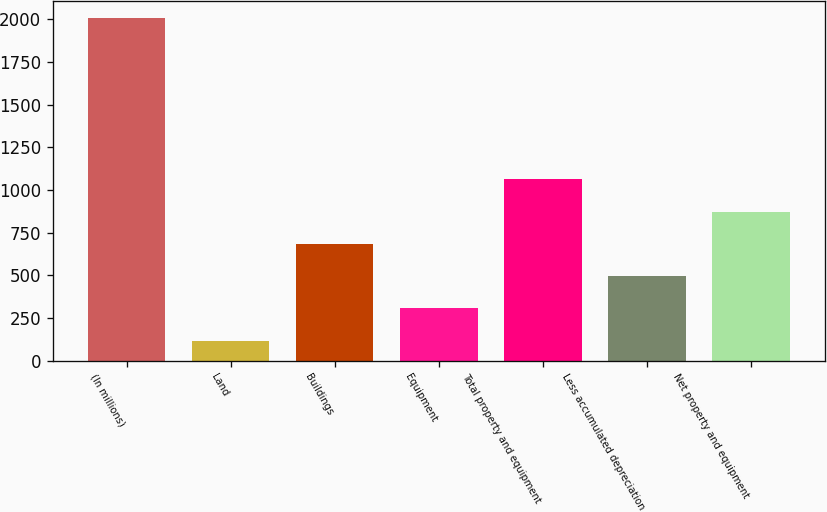Convert chart to OTSL. <chart><loc_0><loc_0><loc_500><loc_500><bar_chart><fcel>(In millions)<fcel>Land<fcel>Buildings<fcel>Equipment<fcel>Total property and equipment<fcel>Less accumulated depreciation<fcel>Net property and equipment<nl><fcel>2006<fcel>118<fcel>684.4<fcel>306.8<fcel>1062<fcel>495.6<fcel>873.2<nl></chart> 